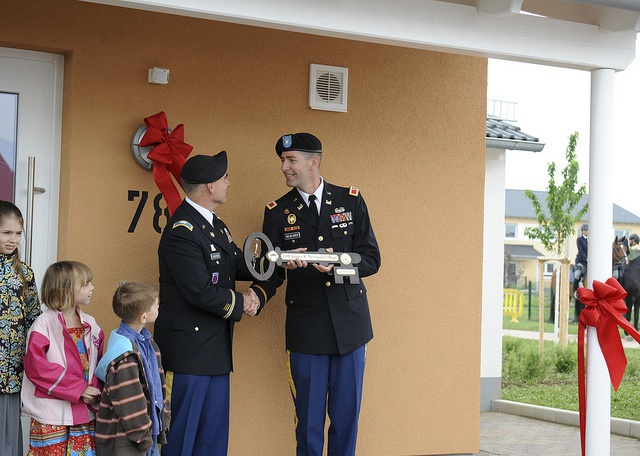Describe the objects in this image and their specific colors. I can see people in maroon, black, navy, darkgray, and tan tones, people in maroon, black, navy, gray, and tan tones, people in maroon, darkgray, and brown tones, people in maroon, black, and gray tones, and people in maroon, gray, black, darkgray, and tan tones in this image. 